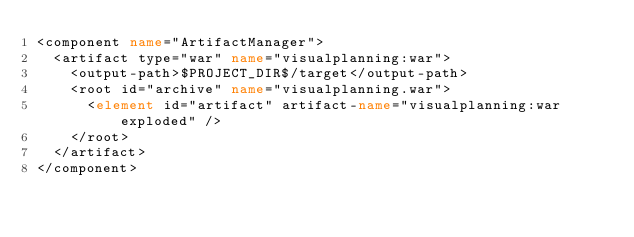<code> <loc_0><loc_0><loc_500><loc_500><_XML_><component name="ArtifactManager">
  <artifact type="war" name="visualplanning:war">
    <output-path>$PROJECT_DIR$/target</output-path>
    <root id="archive" name="visualplanning.war">
      <element id="artifact" artifact-name="visualplanning:war exploded" />
    </root>
  </artifact>
</component></code> 